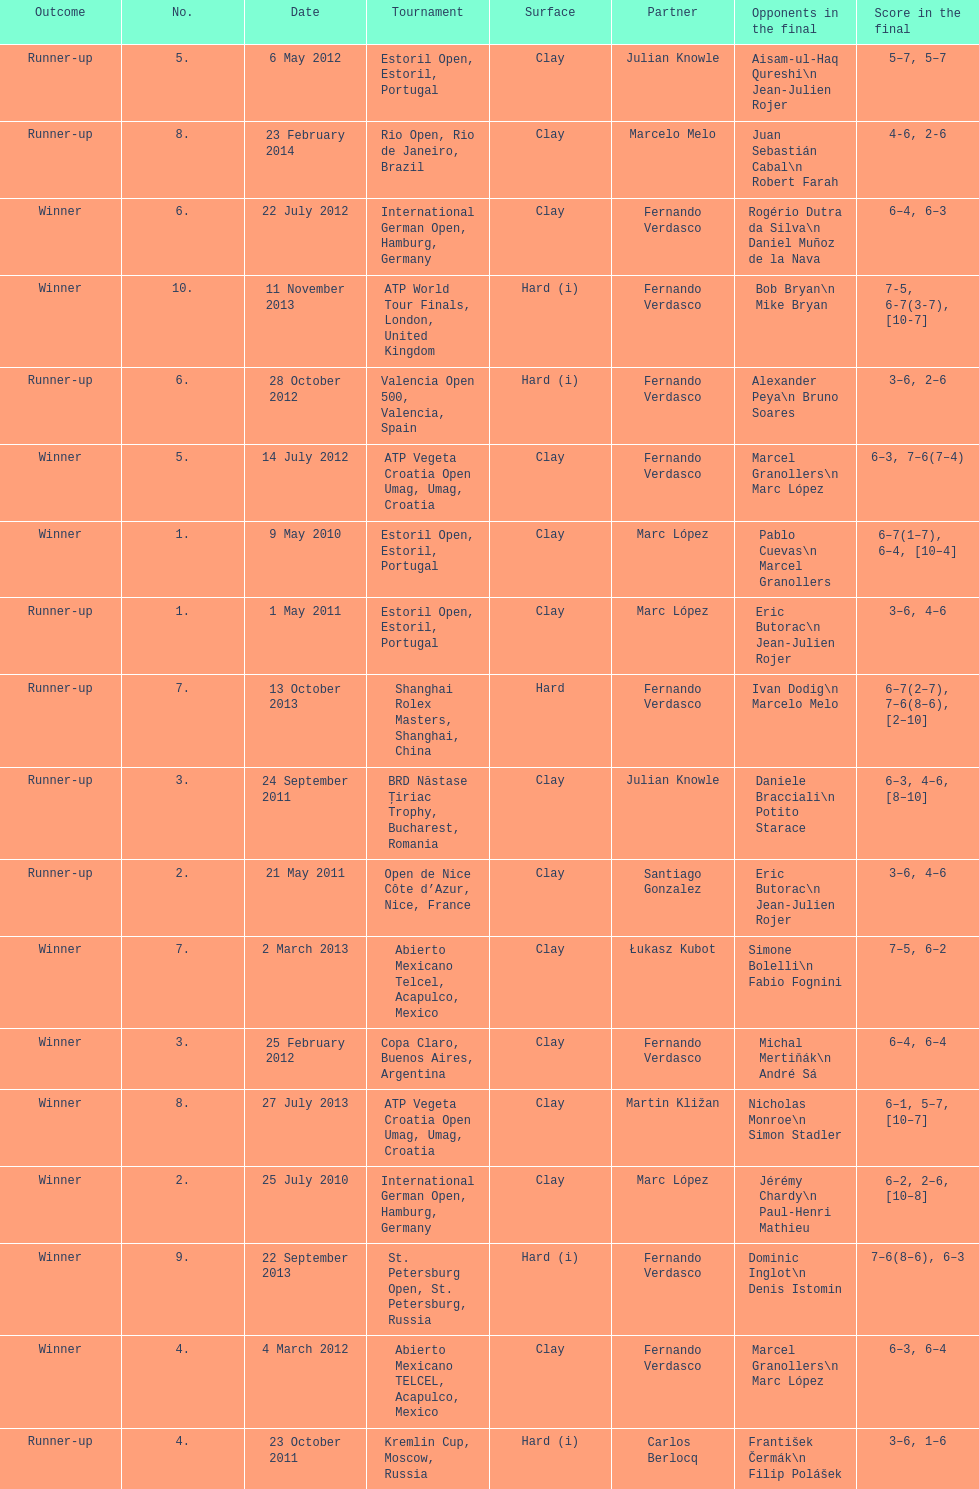Which tournament has the largest number? ATP World Tour Finals. 